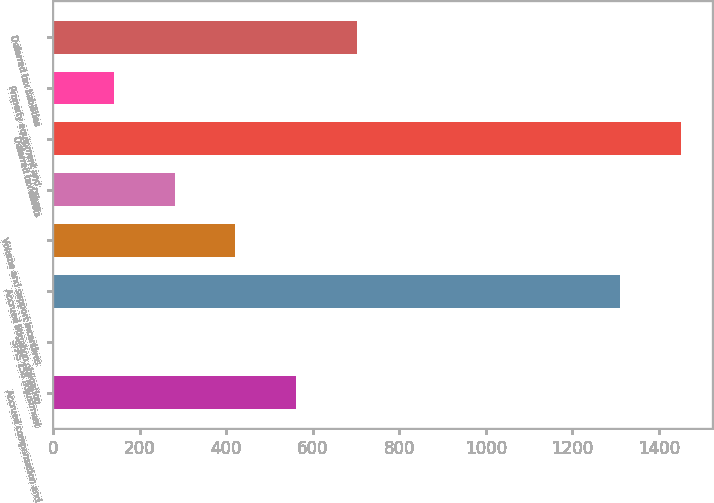Convert chart. <chart><loc_0><loc_0><loc_500><loc_500><bar_chart><fcel>Accrued compensation and<fcel>SFAS 158 adjustment<fcel>Accrued litigation obligation<fcel>Volume and support incentives<fcel>Other<fcel>Deferred tax assets<fcel>Property equipment and<fcel>Deferred tax liabilities<nl><fcel>561.8<fcel>1<fcel>1311<fcel>421.6<fcel>281.4<fcel>1451.2<fcel>141.2<fcel>702<nl></chart> 